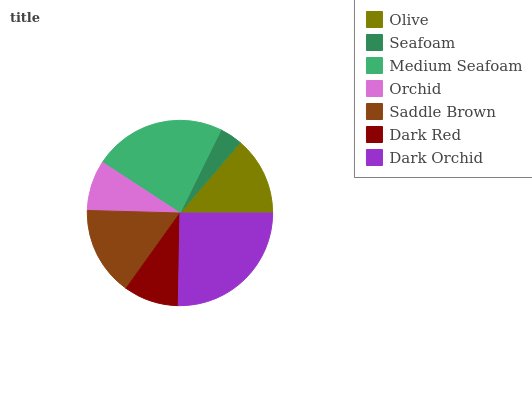Is Seafoam the minimum?
Answer yes or no. Yes. Is Dark Orchid the maximum?
Answer yes or no. Yes. Is Medium Seafoam the minimum?
Answer yes or no. No. Is Medium Seafoam the maximum?
Answer yes or no. No. Is Medium Seafoam greater than Seafoam?
Answer yes or no. Yes. Is Seafoam less than Medium Seafoam?
Answer yes or no. Yes. Is Seafoam greater than Medium Seafoam?
Answer yes or no. No. Is Medium Seafoam less than Seafoam?
Answer yes or no. No. Is Olive the high median?
Answer yes or no. Yes. Is Olive the low median?
Answer yes or no. Yes. Is Dark Orchid the high median?
Answer yes or no. No. Is Medium Seafoam the low median?
Answer yes or no. No. 